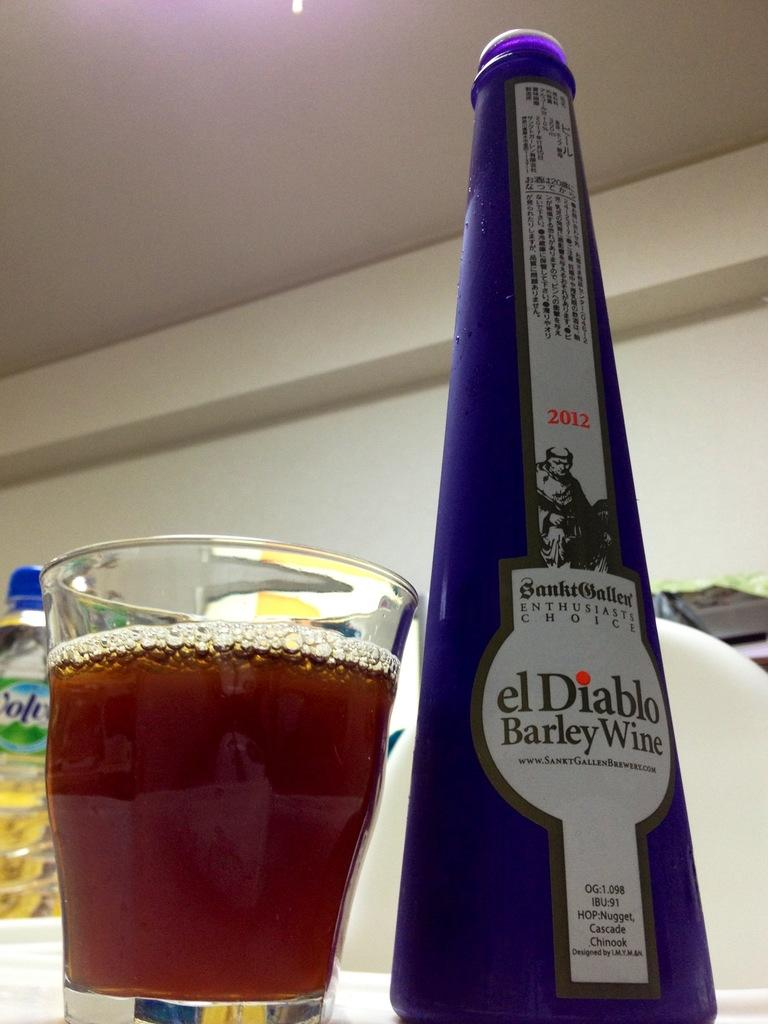<image>
Write a terse but informative summary of the picture. A bottle of El Diable Barley Wine is next to a glass full of beer. 